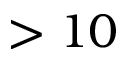Convert formula to latex. <formula><loc_0><loc_0><loc_500><loc_500>> 1 0</formula> 